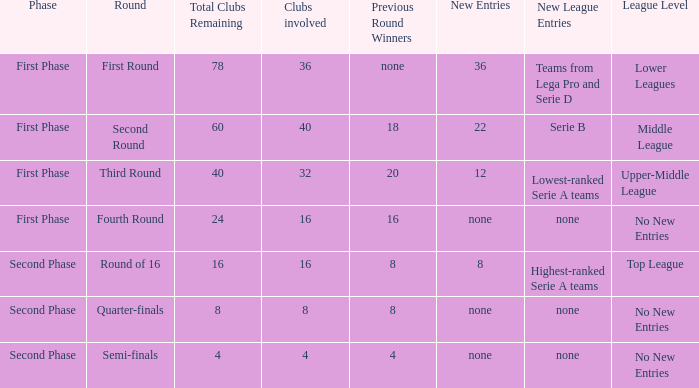If there are 8 clubs involved, what number would you discover from the winners of the previous round? 8.0. 